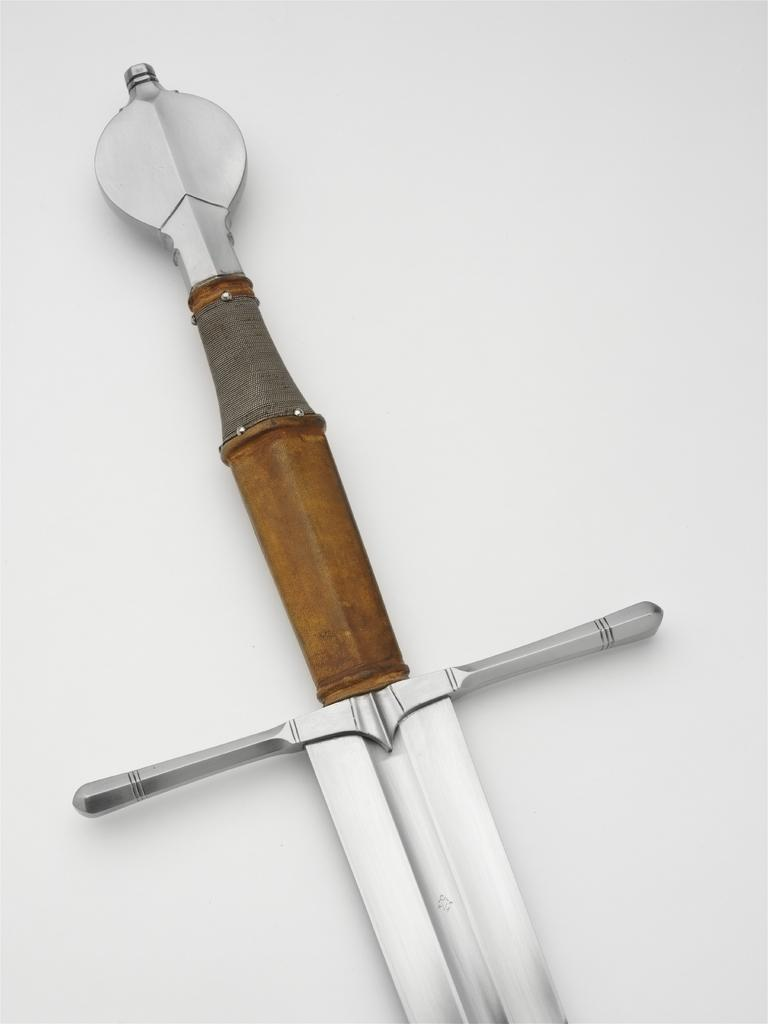What object is present in the image? There is a sword in the image. What is the color of the surface on which the sword is placed? The sword is on a white surface. What type of plantation can be seen in the background of the image? There is no plantation present in the image; it only features a sword on a white surface. 